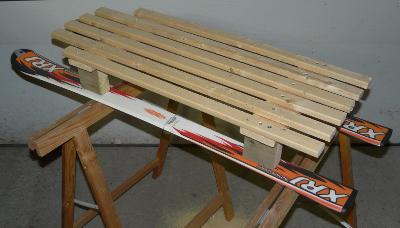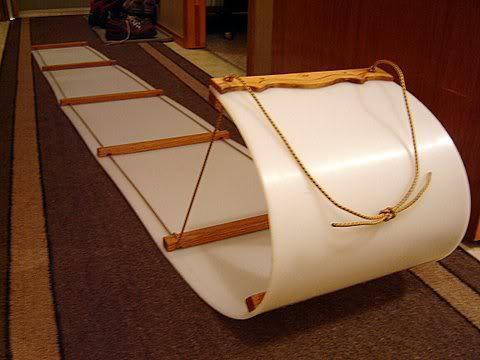The first image is the image on the left, the second image is the image on the right. Examine the images to the left and right. Is the description "There is at least one person pictured with a sled like object." accurate? Answer yes or no. No. The first image is the image on the left, the second image is the image on the right. For the images shown, is this caption "There are two pairs of downhill skis." true? Answer yes or no. No. 